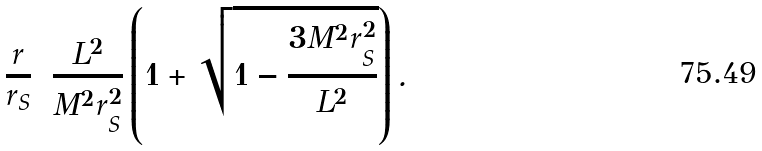<formula> <loc_0><loc_0><loc_500><loc_500>\frac { r } { r _ { S } } = \frac { L ^ { 2 } } { M ^ { 2 } r _ { S } ^ { 2 } } \left ( 1 + \sqrt { 1 - \frac { 3 M ^ { 2 } r _ { S } ^ { 2 } } { L ^ { 2 } } } \right ) .</formula> 